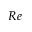<formula> <loc_0><loc_0><loc_500><loc_500>R e</formula> 